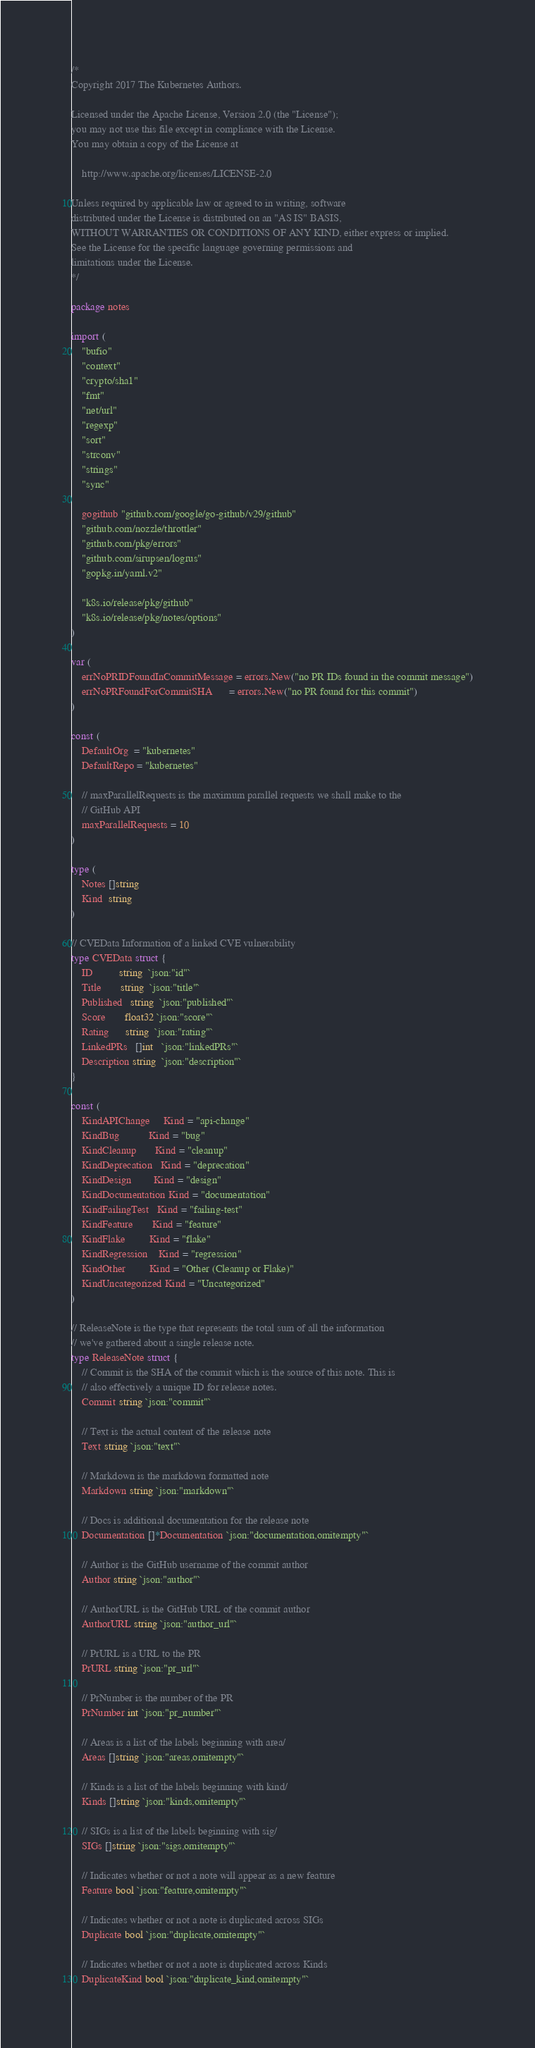Convert code to text. <code><loc_0><loc_0><loc_500><loc_500><_Go_>/*
Copyright 2017 The Kubernetes Authors.

Licensed under the Apache License, Version 2.0 (the "License");
you may not use this file except in compliance with the License.
You may obtain a copy of the License at

    http://www.apache.org/licenses/LICENSE-2.0

Unless required by applicable law or agreed to in writing, software
distributed under the License is distributed on an "AS IS" BASIS,
WITHOUT WARRANTIES OR CONDITIONS OF ANY KIND, either express or implied.
See the License for the specific language governing permissions and
limitations under the License.
*/

package notes

import (
	"bufio"
	"context"
	"crypto/sha1"
	"fmt"
	"net/url"
	"regexp"
	"sort"
	"strconv"
	"strings"
	"sync"

	gogithub "github.com/google/go-github/v29/github"
	"github.com/nozzle/throttler"
	"github.com/pkg/errors"
	"github.com/sirupsen/logrus"
	"gopkg.in/yaml.v2"

	"k8s.io/release/pkg/github"
	"k8s.io/release/pkg/notes/options"
)

var (
	errNoPRIDFoundInCommitMessage = errors.New("no PR IDs found in the commit message")
	errNoPRFoundForCommitSHA      = errors.New("no PR found for this commit")
)

const (
	DefaultOrg  = "kubernetes"
	DefaultRepo = "kubernetes"

	// maxParallelRequests is the maximum parallel requests we shall make to the
	// GitHub API
	maxParallelRequests = 10
)

type (
	Notes []string
	Kind  string
)

// CVEData Information of a linked CVE vulnerability
type CVEData struct {
	ID          string  `json:"id"`
	Title       string  `json:"title"`
	Published   string  `json:"published"`
	Score       float32 `json:"score"`
	Rating      string  `json:"rating"`
	LinkedPRs   []int   `json:"linkedPRs"`
	Description string  `json:"description"`
}

const (
	KindAPIChange     Kind = "api-change"
	KindBug           Kind = "bug"
	KindCleanup       Kind = "cleanup"
	KindDeprecation   Kind = "deprecation"
	KindDesign        Kind = "design"
	KindDocumentation Kind = "documentation"
	KindFailingTest   Kind = "failing-test"
	KindFeature       Kind = "feature"
	KindFlake         Kind = "flake"
	KindRegression    Kind = "regression"
	KindOther         Kind = "Other (Cleanup or Flake)"
	KindUncategorized Kind = "Uncategorized"
)

// ReleaseNote is the type that represents the total sum of all the information
// we've gathered about a single release note.
type ReleaseNote struct {
	// Commit is the SHA of the commit which is the source of this note. This is
	// also effectively a unique ID for release notes.
	Commit string `json:"commit"`

	// Text is the actual content of the release note
	Text string `json:"text"`

	// Markdown is the markdown formatted note
	Markdown string `json:"markdown"`

	// Docs is additional documentation for the release note
	Documentation []*Documentation `json:"documentation,omitempty"`

	// Author is the GitHub username of the commit author
	Author string `json:"author"`

	// AuthorURL is the GitHub URL of the commit author
	AuthorURL string `json:"author_url"`

	// PrURL is a URL to the PR
	PrURL string `json:"pr_url"`

	// PrNumber is the number of the PR
	PrNumber int `json:"pr_number"`

	// Areas is a list of the labels beginning with area/
	Areas []string `json:"areas,omitempty"`

	// Kinds is a list of the labels beginning with kind/
	Kinds []string `json:"kinds,omitempty"`

	// SIGs is a list of the labels beginning with sig/
	SIGs []string `json:"sigs,omitempty"`

	// Indicates whether or not a note will appear as a new feature
	Feature bool `json:"feature,omitempty"`

	// Indicates whether or not a note is duplicated across SIGs
	Duplicate bool `json:"duplicate,omitempty"`

	// Indicates whether or not a note is duplicated across Kinds
	DuplicateKind bool `json:"duplicate_kind,omitempty"`
</code> 